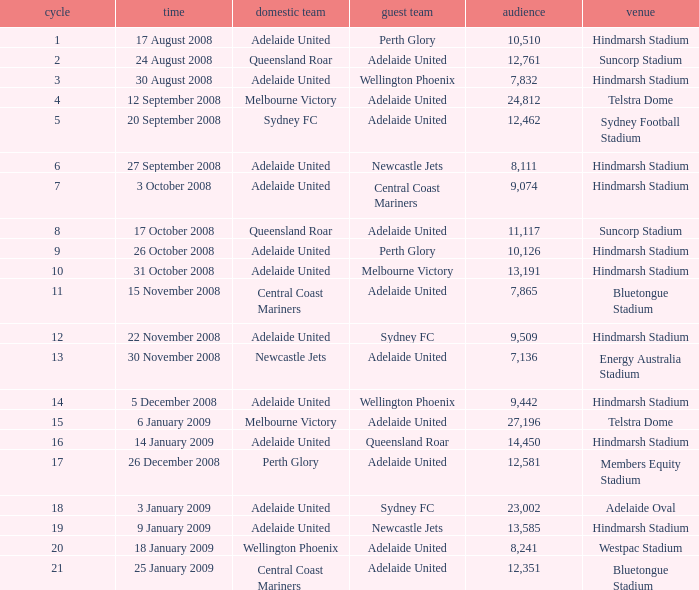What is the least round for the game played at Members Equity Stadium in from of 12,581 people? None. 